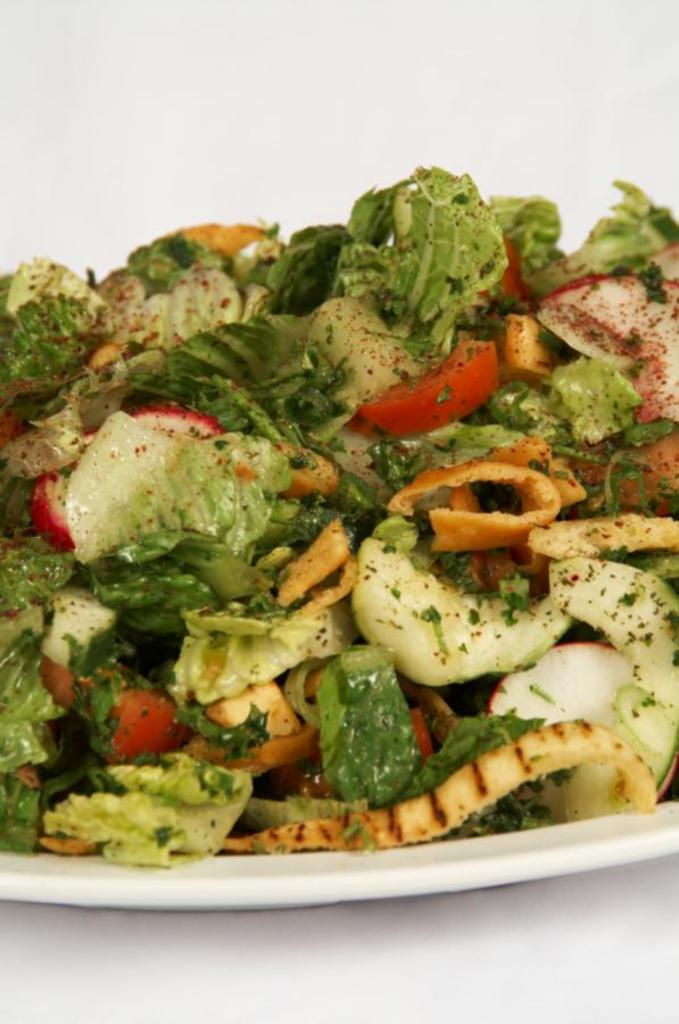Can you describe this image briefly? In this image, we can see food on the white plate. At the bottom of the image, we can see the surface. Top of the image, we can see the white color. 